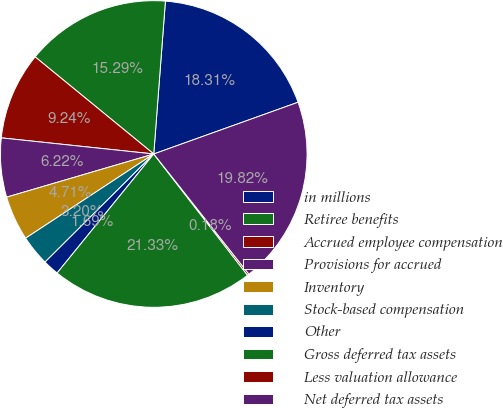<chart> <loc_0><loc_0><loc_500><loc_500><pie_chart><fcel>in millions<fcel>Retiree benefits<fcel>Accrued employee compensation<fcel>Provisions for accrued<fcel>Inventory<fcel>Stock-based compensation<fcel>Other<fcel>Gross deferred tax assets<fcel>Less valuation allowance<fcel>Net deferred tax assets<nl><fcel>18.31%<fcel>15.29%<fcel>9.24%<fcel>6.22%<fcel>4.71%<fcel>3.2%<fcel>1.69%<fcel>21.33%<fcel>0.18%<fcel>19.82%<nl></chart> 